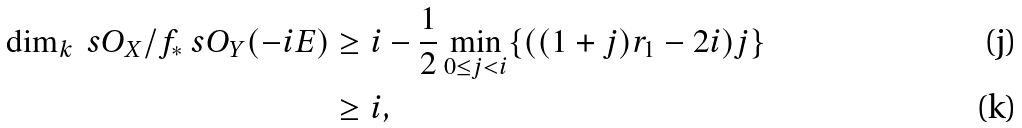Convert formula to latex. <formula><loc_0><loc_0><loc_500><loc_500>\dim _ { k } \ s O _ { X } / f _ { * } \ s O _ { Y } ( - i E ) & \geq i - \frac { 1 } { 2 } \min _ { 0 \leq j < i } \{ ( ( 1 + j ) r _ { 1 } - 2 i ) j \} \\ & \geq i ,</formula> 